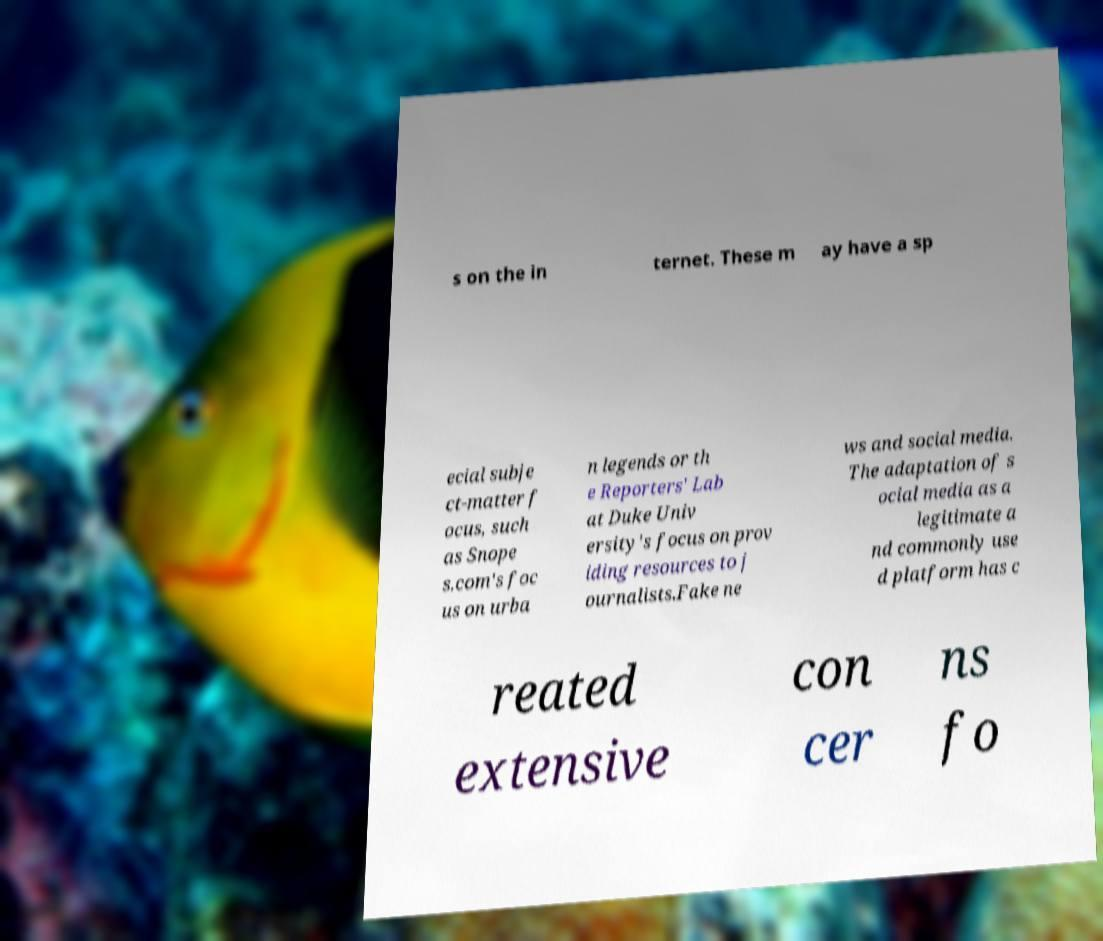For documentation purposes, I need the text within this image transcribed. Could you provide that? s on the in ternet. These m ay have a sp ecial subje ct-matter f ocus, such as Snope s.com's foc us on urba n legends or th e Reporters' Lab at Duke Univ ersity's focus on prov iding resources to j ournalists.Fake ne ws and social media. The adaptation of s ocial media as a legitimate a nd commonly use d platform has c reated extensive con cer ns fo 